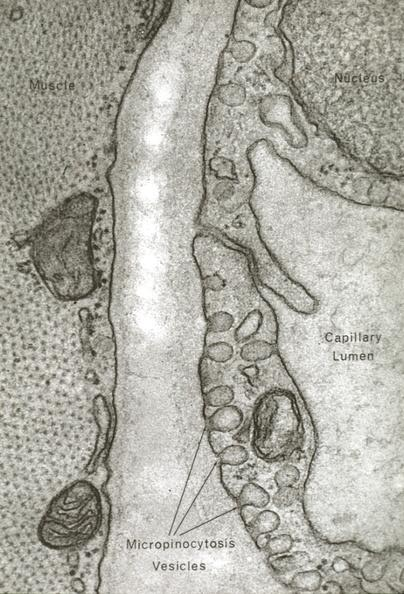what does this image show?
Answer the question using a single word or phrase. Skeletal muscle 